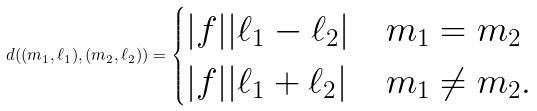<formula> <loc_0><loc_0><loc_500><loc_500>d ( ( m _ { 1 } , \ell _ { 1 } ) , ( m _ { 2 } , \ell _ { 2 } ) ) = \begin{cases} | f | | \ell _ { 1 } - \ell _ { 2 } | & m _ { 1 } = m _ { 2 } \\ | f | | \ell _ { 1 } + \ell _ { 2 } | & m _ { 1 } \neq m _ { 2 } . \end{cases}</formula> 